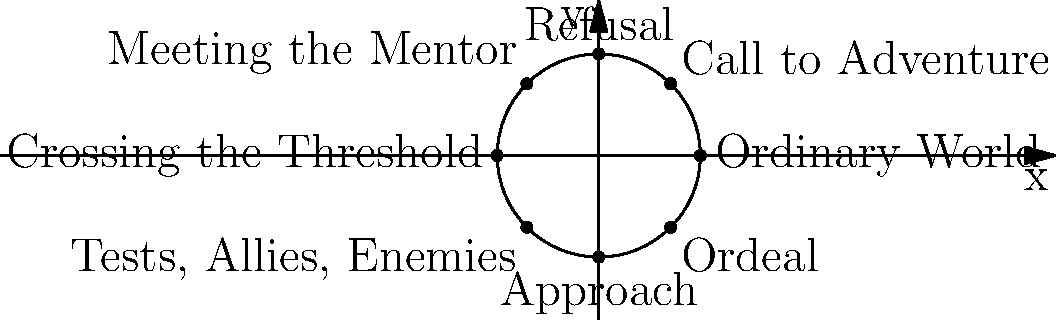In the hero's journey circular path illustrated on the coordinate plane, what are the coordinates of the point representing the "Crossing the Threshold" stage? Express your answer as an ordered pair $(x,y)$. To find the coordinates of the "Crossing the Threshold" stage:

1. Observe that the circle is centered at the origin (0,0).
2. The radius of the circle is 3 units.
3. "Crossing the Threshold" is located on the negative x-axis.
4. For a point on a circle with radius $r$:
   - x-coordinate = $r \cos \theta$
   - y-coordinate = $r \sin \theta$
5. "Crossing the Threshold" is at angle $\theta = \pi$ radians or 180°.
6. Calculate the coordinates:
   - x = $3 \cos \pi = -3$
   - y = $3 \sin \pi = 0$

Therefore, the coordinates of "Crossing the Threshold" are $(-3, 0)$.
Answer: $(-3, 0)$ 